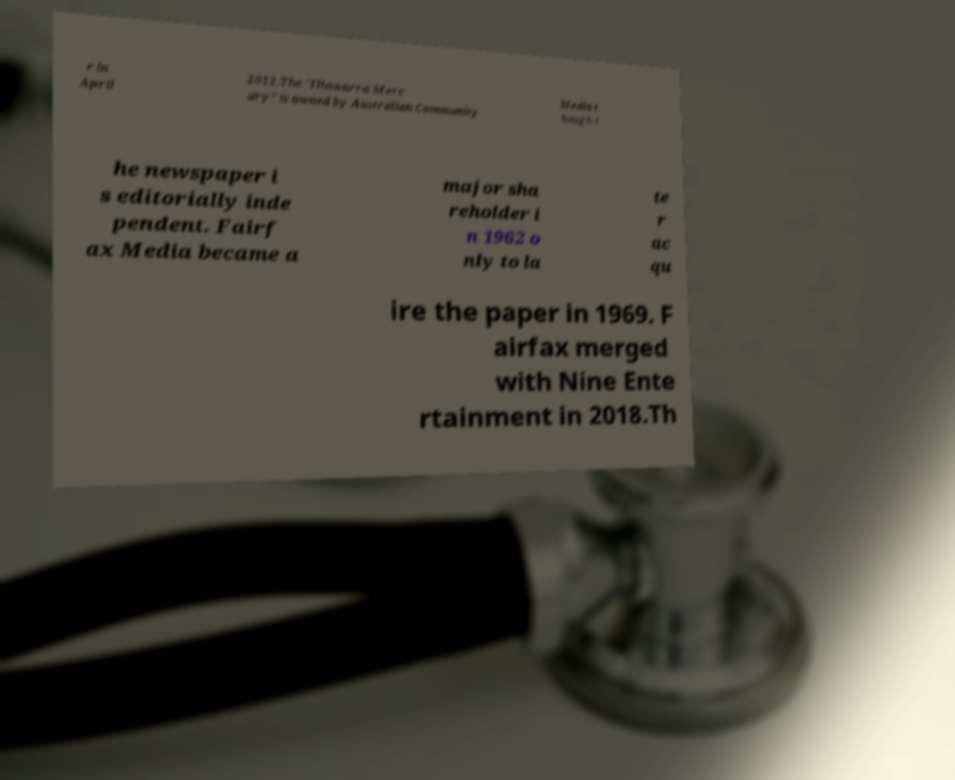I need the written content from this picture converted into text. Can you do that? r in April 2012.The "Illawarra Merc ury" is owned by Australian Community Media t hough t he newspaper i s editorially inde pendent. Fairf ax Media became a major sha reholder i n 1962 o nly to la te r ac qu ire the paper in 1969. F airfax merged with Nine Ente rtainment in 2018.Th 